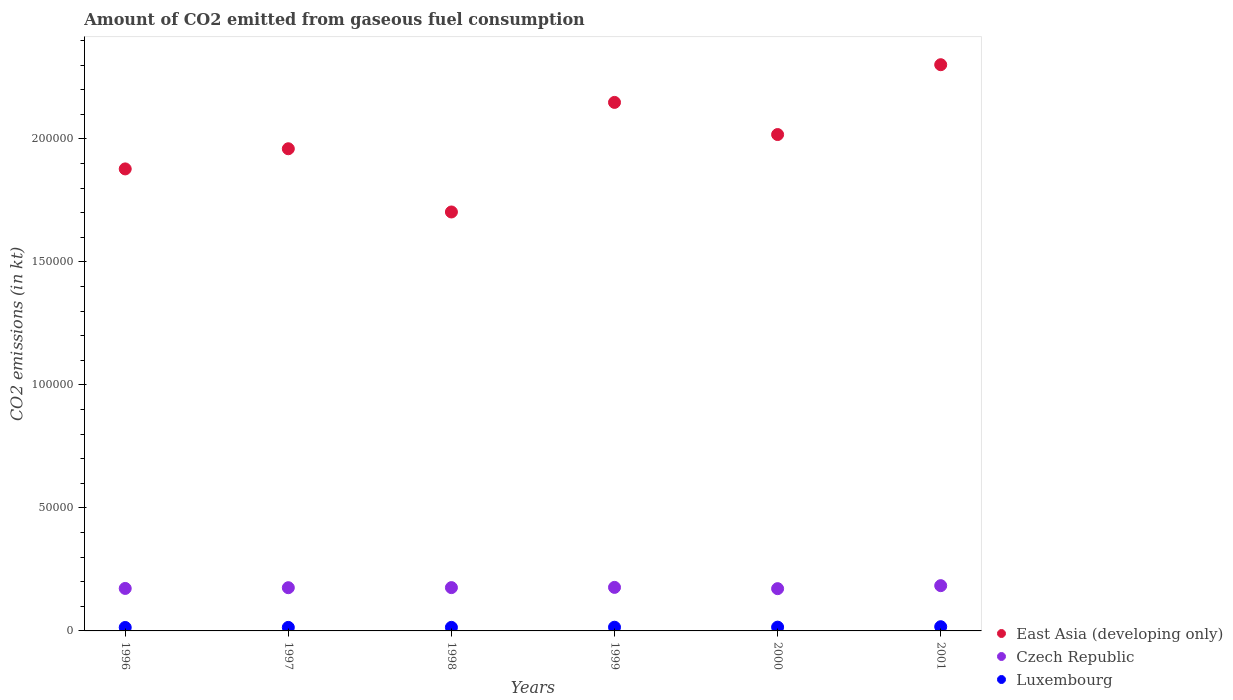What is the amount of CO2 emitted in East Asia (developing only) in 1996?
Offer a terse response. 1.88e+05. Across all years, what is the maximum amount of CO2 emitted in Luxembourg?
Provide a short and direct response. 1708.82. Across all years, what is the minimum amount of CO2 emitted in Luxembourg?
Your answer should be very brief. 1400.79. In which year was the amount of CO2 emitted in Luxembourg maximum?
Your answer should be very brief. 2001. What is the total amount of CO2 emitted in East Asia (developing only) in the graph?
Your answer should be compact. 1.20e+06. What is the difference between the amount of CO2 emitted in Luxembourg in 1996 and that in 2001?
Keep it short and to the point. -308.03. What is the difference between the amount of CO2 emitted in Luxembourg in 1998 and the amount of CO2 emitted in Czech Republic in 1997?
Ensure brevity in your answer.  -1.61e+04. What is the average amount of CO2 emitted in East Asia (developing only) per year?
Make the answer very short. 2.00e+05. In the year 1996, what is the difference between the amount of CO2 emitted in Luxembourg and amount of CO2 emitted in East Asia (developing only)?
Your answer should be compact. -1.86e+05. In how many years, is the amount of CO2 emitted in East Asia (developing only) greater than 50000 kt?
Your response must be concise. 6. What is the ratio of the amount of CO2 emitted in Luxembourg in 1999 to that in 2000?
Provide a succinct answer. 0.98. Is the amount of CO2 emitted in Luxembourg in 1997 less than that in 2001?
Your answer should be very brief. Yes. What is the difference between the highest and the second highest amount of CO2 emitted in Czech Republic?
Make the answer very short. 700.4. What is the difference between the highest and the lowest amount of CO2 emitted in Czech Republic?
Your response must be concise. 1221.11. In how many years, is the amount of CO2 emitted in Czech Republic greater than the average amount of CO2 emitted in Czech Republic taken over all years?
Keep it short and to the point. 2. Is the sum of the amount of CO2 emitted in Luxembourg in 1998 and 2000 greater than the maximum amount of CO2 emitted in East Asia (developing only) across all years?
Give a very brief answer. No. Is it the case that in every year, the sum of the amount of CO2 emitted in Czech Republic and amount of CO2 emitted in Luxembourg  is greater than the amount of CO2 emitted in East Asia (developing only)?
Your response must be concise. No. Does the amount of CO2 emitted in East Asia (developing only) monotonically increase over the years?
Ensure brevity in your answer.  No. How many dotlines are there?
Make the answer very short. 3. Does the graph contain any zero values?
Ensure brevity in your answer.  No. How are the legend labels stacked?
Provide a short and direct response. Vertical. What is the title of the graph?
Your response must be concise. Amount of CO2 emitted from gaseous fuel consumption. Does "Albania" appear as one of the legend labels in the graph?
Provide a short and direct response. No. What is the label or title of the Y-axis?
Make the answer very short. CO2 emissions (in kt). What is the CO2 emissions (in kt) in East Asia (developing only) in 1996?
Your answer should be compact. 1.88e+05. What is the CO2 emissions (in kt) of Czech Republic in 1996?
Provide a short and direct response. 1.73e+04. What is the CO2 emissions (in kt) in Luxembourg in 1996?
Ensure brevity in your answer.  1400.79. What is the CO2 emissions (in kt) of East Asia (developing only) in 1997?
Keep it short and to the point. 1.96e+05. What is the CO2 emissions (in kt) of Czech Republic in 1997?
Your response must be concise. 1.76e+04. What is the CO2 emissions (in kt) in Luxembourg in 1997?
Your response must be concise. 1433.8. What is the CO2 emissions (in kt) of East Asia (developing only) in 1998?
Provide a succinct answer. 1.70e+05. What is the CO2 emissions (in kt) of Czech Republic in 1998?
Your answer should be compact. 1.76e+04. What is the CO2 emissions (in kt) in Luxembourg in 1998?
Ensure brevity in your answer.  1448.46. What is the CO2 emissions (in kt) of East Asia (developing only) in 1999?
Give a very brief answer. 2.15e+05. What is the CO2 emissions (in kt) in Czech Republic in 1999?
Make the answer very short. 1.77e+04. What is the CO2 emissions (in kt) in Luxembourg in 1999?
Your answer should be compact. 1503.47. What is the CO2 emissions (in kt) of East Asia (developing only) in 2000?
Offer a very short reply. 2.02e+05. What is the CO2 emissions (in kt) in Czech Republic in 2000?
Make the answer very short. 1.72e+04. What is the CO2 emissions (in kt) in Luxembourg in 2000?
Keep it short and to the point. 1536.47. What is the CO2 emissions (in kt) of East Asia (developing only) in 2001?
Your answer should be very brief. 2.30e+05. What is the CO2 emissions (in kt) in Czech Republic in 2001?
Give a very brief answer. 1.84e+04. What is the CO2 emissions (in kt) in Luxembourg in 2001?
Ensure brevity in your answer.  1708.82. Across all years, what is the maximum CO2 emissions (in kt) in East Asia (developing only)?
Offer a terse response. 2.30e+05. Across all years, what is the maximum CO2 emissions (in kt) in Czech Republic?
Ensure brevity in your answer.  1.84e+04. Across all years, what is the maximum CO2 emissions (in kt) of Luxembourg?
Your answer should be very brief. 1708.82. Across all years, what is the minimum CO2 emissions (in kt) of East Asia (developing only)?
Provide a short and direct response. 1.70e+05. Across all years, what is the minimum CO2 emissions (in kt) of Czech Republic?
Your answer should be very brief. 1.72e+04. Across all years, what is the minimum CO2 emissions (in kt) in Luxembourg?
Provide a short and direct response. 1400.79. What is the total CO2 emissions (in kt) of East Asia (developing only) in the graph?
Provide a short and direct response. 1.20e+06. What is the total CO2 emissions (in kt) of Czech Republic in the graph?
Your response must be concise. 1.06e+05. What is the total CO2 emissions (in kt) of Luxembourg in the graph?
Your response must be concise. 9031.82. What is the difference between the CO2 emissions (in kt) in East Asia (developing only) in 1996 and that in 1997?
Ensure brevity in your answer.  -8193. What is the difference between the CO2 emissions (in kt) in Czech Republic in 1996 and that in 1997?
Provide a succinct answer. -297.03. What is the difference between the CO2 emissions (in kt) in Luxembourg in 1996 and that in 1997?
Provide a succinct answer. -33. What is the difference between the CO2 emissions (in kt) of East Asia (developing only) in 1996 and that in 1998?
Ensure brevity in your answer.  1.75e+04. What is the difference between the CO2 emissions (in kt) in Czech Republic in 1996 and that in 1998?
Ensure brevity in your answer.  -333.7. What is the difference between the CO2 emissions (in kt) in Luxembourg in 1996 and that in 1998?
Offer a terse response. -47.67. What is the difference between the CO2 emissions (in kt) of East Asia (developing only) in 1996 and that in 1999?
Your answer should be compact. -2.70e+04. What is the difference between the CO2 emissions (in kt) of Czech Republic in 1996 and that in 1999?
Your answer should be compact. -429.04. What is the difference between the CO2 emissions (in kt) in Luxembourg in 1996 and that in 1999?
Give a very brief answer. -102.68. What is the difference between the CO2 emissions (in kt) in East Asia (developing only) in 1996 and that in 2000?
Provide a short and direct response. -1.40e+04. What is the difference between the CO2 emissions (in kt) of Czech Republic in 1996 and that in 2000?
Provide a succinct answer. 91.67. What is the difference between the CO2 emissions (in kt) in Luxembourg in 1996 and that in 2000?
Provide a succinct answer. -135.68. What is the difference between the CO2 emissions (in kt) in East Asia (developing only) in 1996 and that in 2001?
Your answer should be very brief. -4.24e+04. What is the difference between the CO2 emissions (in kt) of Czech Republic in 1996 and that in 2001?
Your response must be concise. -1129.44. What is the difference between the CO2 emissions (in kt) of Luxembourg in 1996 and that in 2001?
Your answer should be very brief. -308.03. What is the difference between the CO2 emissions (in kt) in East Asia (developing only) in 1997 and that in 1998?
Your answer should be compact. 2.57e+04. What is the difference between the CO2 emissions (in kt) in Czech Republic in 1997 and that in 1998?
Your answer should be compact. -36.67. What is the difference between the CO2 emissions (in kt) of Luxembourg in 1997 and that in 1998?
Offer a terse response. -14.67. What is the difference between the CO2 emissions (in kt) of East Asia (developing only) in 1997 and that in 1999?
Offer a very short reply. -1.88e+04. What is the difference between the CO2 emissions (in kt) of Czech Republic in 1997 and that in 1999?
Make the answer very short. -132.01. What is the difference between the CO2 emissions (in kt) of Luxembourg in 1997 and that in 1999?
Offer a very short reply. -69.67. What is the difference between the CO2 emissions (in kt) of East Asia (developing only) in 1997 and that in 2000?
Give a very brief answer. -5774.36. What is the difference between the CO2 emissions (in kt) of Czech Republic in 1997 and that in 2000?
Keep it short and to the point. 388.7. What is the difference between the CO2 emissions (in kt) of Luxembourg in 1997 and that in 2000?
Provide a succinct answer. -102.68. What is the difference between the CO2 emissions (in kt) of East Asia (developing only) in 1997 and that in 2001?
Offer a very short reply. -3.42e+04. What is the difference between the CO2 emissions (in kt) of Czech Republic in 1997 and that in 2001?
Offer a very short reply. -832.41. What is the difference between the CO2 emissions (in kt) in Luxembourg in 1997 and that in 2001?
Make the answer very short. -275.02. What is the difference between the CO2 emissions (in kt) of East Asia (developing only) in 1998 and that in 1999?
Your answer should be very brief. -4.45e+04. What is the difference between the CO2 emissions (in kt) of Czech Republic in 1998 and that in 1999?
Your answer should be very brief. -95.34. What is the difference between the CO2 emissions (in kt) in Luxembourg in 1998 and that in 1999?
Keep it short and to the point. -55.01. What is the difference between the CO2 emissions (in kt) in East Asia (developing only) in 1998 and that in 2000?
Provide a succinct answer. -3.15e+04. What is the difference between the CO2 emissions (in kt) in Czech Republic in 1998 and that in 2000?
Your answer should be compact. 425.37. What is the difference between the CO2 emissions (in kt) in Luxembourg in 1998 and that in 2000?
Provide a succinct answer. -88.01. What is the difference between the CO2 emissions (in kt) in East Asia (developing only) in 1998 and that in 2001?
Your answer should be compact. -5.99e+04. What is the difference between the CO2 emissions (in kt) in Czech Republic in 1998 and that in 2001?
Keep it short and to the point. -795.74. What is the difference between the CO2 emissions (in kt) in Luxembourg in 1998 and that in 2001?
Give a very brief answer. -260.36. What is the difference between the CO2 emissions (in kt) of East Asia (developing only) in 1999 and that in 2000?
Your response must be concise. 1.31e+04. What is the difference between the CO2 emissions (in kt) of Czech Republic in 1999 and that in 2000?
Provide a succinct answer. 520.71. What is the difference between the CO2 emissions (in kt) in Luxembourg in 1999 and that in 2000?
Keep it short and to the point. -33. What is the difference between the CO2 emissions (in kt) in East Asia (developing only) in 1999 and that in 2001?
Give a very brief answer. -1.53e+04. What is the difference between the CO2 emissions (in kt) in Czech Republic in 1999 and that in 2001?
Offer a terse response. -700.4. What is the difference between the CO2 emissions (in kt) in Luxembourg in 1999 and that in 2001?
Keep it short and to the point. -205.35. What is the difference between the CO2 emissions (in kt) in East Asia (developing only) in 2000 and that in 2001?
Provide a succinct answer. -2.84e+04. What is the difference between the CO2 emissions (in kt) in Czech Republic in 2000 and that in 2001?
Offer a terse response. -1221.11. What is the difference between the CO2 emissions (in kt) in Luxembourg in 2000 and that in 2001?
Provide a short and direct response. -172.35. What is the difference between the CO2 emissions (in kt) in East Asia (developing only) in 1996 and the CO2 emissions (in kt) in Czech Republic in 1997?
Offer a terse response. 1.70e+05. What is the difference between the CO2 emissions (in kt) in East Asia (developing only) in 1996 and the CO2 emissions (in kt) in Luxembourg in 1997?
Make the answer very short. 1.86e+05. What is the difference between the CO2 emissions (in kt) of Czech Republic in 1996 and the CO2 emissions (in kt) of Luxembourg in 1997?
Offer a very short reply. 1.58e+04. What is the difference between the CO2 emissions (in kt) in East Asia (developing only) in 1996 and the CO2 emissions (in kt) in Czech Republic in 1998?
Provide a short and direct response. 1.70e+05. What is the difference between the CO2 emissions (in kt) in East Asia (developing only) in 1996 and the CO2 emissions (in kt) in Luxembourg in 1998?
Provide a succinct answer. 1.86e+05. What is the difference between the CO2 emissions (in kt) of Czech Republic in 1996 and the CO2 emissions (in kt) of Luxembourg in 1998?
Give a very brief answer. 1.58e+04. What is the difference between the CO2 emissions (in kt) in East Asia (developing only) in 1996 and the CO2 emissions (in kt) in Czech Republic in 1999?
Make the answer very short. 1.70e+05. What is the difference between the CO2 emissions (in kt) in East Asia (developing only) in 1996 and the CO2 emissions (in kt) in Luxembourg in 1999?
Offer a very short reply. 1.86e+05. What is the difference between the CO2 emissions (in kt) in Czech Republic in 1996 and the CO2 emissions (in kt) in Luxembourg in 1999?
Offer a very short reply. 1.58e+04. What is the difference between the CO2 emissions (in kt) of East Asia (developing only) in 1996 and the CO2 emissions (in kt) of Czech Republic in 2000?
Provide a short and direct response. 1.71e+05. What is the difference between the CO2 emissions (in kt) in East Asia (developing only) in 1996 and the CO2 emissions (in kt) in Luxembourg in 2000?
Make the answer very short. 1.86e+05. What is the difference between the CO2 emissions (in kt) of Czech Republic in 1996 and the CO2 emissions (in kt) of Luxembourg in 2000?
Provide a short and direct response. 1.57e+04. What is the difference between the CO2 emissions (in kt) of East Asia (developing only) in 1996 and the CO2 emissions (in kt) of Czech Republic in 2001?
Give a very brief answer. 1.69e+05. What is the difference between the CO2 emissions (in kt) of East Asia (developing only) in 1996 and the CO2 emissions (in kt) of Luxembourg in 2001?
Offer a terse response. 1.86e+05. What is the difference between the CO2 emissions (in kt) of Czech Republic in 1996 and the CO2 emissions (in kt) of Luxembourg in 2001?
Your answer should be compact. 1.56e+04. What is the difference between the CO2 emissions (in kt) in East Asia (developing only) in 1997 and the CO2 emissions (in kt) in Czech Republic in 1998?
Offer a very short reply. 1.78e+05. What is the difference between the CO2 emissions (in kt) in East Asia (developing only) in 1997 and the CO2 emissions (in kt) in Luxembourg in 1998?
Your answer should be very brief. 1.95e+05. What is the difference between the CO2 emissions (in kt) in Czech Republic in 1997 and the CO2 emissions (in kt) in Luxembourg in 1998?
Give a very brief answer. 1.61e+04. What is the difference between the CO2 emissions (in kt) in East Asia (developing only) in 1997 and the CO2 emissions (in kt) in Czech Republic in 1999?
Your response must be concise. 1.78e+05. What is the difference between the CO2 emissions (in kt) in East Asia (developing only) in 1997 and the CO2 emissions (in kt) in Luxembourg in 1999?
Keep it short and to the point. 1.94e+05. What is the difference between the CO2 emissions (in kt) in Czech Republic in 1997 and the CO2 emissions (in kt) in Luxembourg in 1999?
Make the answer very short. 1.61e+04. What is the difference between the CO2 emissions (in kt) of East Asia (developing only) in 1997 and the CO2 emissions (in kt) of Czech Republic in 2000?
Your answer should be very brief. 1.79e+05. What is the difference between the CO2 emissions (in kt) in East Asia (developing only) in 1997 and the CO2 emissions (in kt) in Luxembourg in 2000?
Offer a very short reply. 1.94e+05. What is the difference between the CO2 emissions (in kt) of Czech Republic in 1997 and the CO2 emissions (in kt) of Luxembourg in 2000?
Your answer should be very brief. 1.60e+04. What is the difference between the CO2 emissions (in kt) of East Asia (developing only) in 1997 and the CO2 emissions (in kt) of Czech Republic in 2001?
Give a very brief answer. 1.78e+05. What is the difference between the CO2 emissions (in kt) in East Asia (developing only) in 1997 and the CO2 emissions (in kt) in Luxembourg in 2001?
Keep it short and to the point. 1.94e+05. What is the difference between the CO2 emissions (in kt) of Czech Republic in 1997 and the CO2 emissions (in kt) of Luxembourg in 2001?
Your answer should be compact. 1.59e+04. What is the difference between the CO2 emissions (in kt) in East Asia (developing only) in 1998 and the CO2 emissions (in kt) in Czech Republic in 1999?
Your response must be concise. 1.53e+05. What is the difference between the CO2 emissions (in kt) in East Asia (developing only) in 1998 and the CO2 emissions (in kt) in Luxembourg in 1999?
Provide a succinct answer. 1.69e+05. What is the difference between the CO2 emissions (in kt) of Czech Republic in 1998 and the CO2 emissions (in kt) of Luxembourg in 1999?
Give a very brief answer. 1.61e+04. What is the difference between the CO2 emissions (in kt) of East Asia (developing only) in 1998 and the CO2 emissions (in kt) of Czech Republic in 2000?
Provide a short and direct response. 1.53e+05. What is the difference between the CO2 emissions (in kt) in East Asia (developing only) in 1998 and the CO2 emissions (in kt) in Luxembourg in 2000?
Your answer should be compact. 1.69e+05. What is the difference between the CO2 emissions (in kt) in Czech Republic in 1998 and the CO2 emissions (in kt) in Luxembourg in 2000?
Offer a very short reply. 1.61e+04. What is the difference between the CO2 emissions (in kt) of East Asia (developing only) in 1998 and the CO2 emissions (in kt) of Czech Republic in 2001?
Your answer should be very brief. 1.52e+05. What is the difference between the CO2 emissions (in kt) of East Asia (developing only) in 1998 and the CO2 emissions (in kt) of Luxembourg in 2001?
Your response must be concise. 1.69e+05. What is the difference between the CO2 emissions (in kt) in Czech Republic in 1998 and the CO2 emissions (in kt) in Luxembourg in 2001?
Give a very brief answer. 1.59e+04. What is the difference between the CO2 emissions (in kt) of East Asia (developing only) in 1999 and the CO2 emissions (in kt) of Czech Republic in 2000?
Your answer should be very brief. 1.98e+05. What is the difference between the CO2 emissions (in kt) of East Asia (developing only) in 1999 and the CO2 emissions (in kt) of Luxembourg in 2000?
Give a very brief answer. 2.13e+05. What is the difference between the CO2 emissions (in kt) of Czech Republic in 1999 and the CO2 emissions (in kt) of Luxembourg in 2000?
Offer a very short reply. 1.62e+04. What is the difference between the CO2 emissions (in kt) in East Asia (developing only) in 1999 and the CO2 emissions (in kt) in Czech Republic in 2001?
Make the answer very short. 1.96e+05. What is the difference between the CO2 emissions (in kt) in East Asia (developing only) in 1999 and the CO2 emissions (in kt) in Luxembourg in 2001?
Keep it short and to the point. 2.13e+05. What is the difference between the CO2 emissions (in kt) of Czech Republic in 1999 and the CO2 emissions (in kt) of Luxembourg in 2001?
Ensure brevity in your answer.  1.60e+04. What is the difference between the CO2 emissions (in kt) of East Asia (developing only) in 2000 and the CO2 emissions (in kt) of Czech Republic in 2001?
Provide a succinct answer. 1.83e+05. What is the difference between the CO2 emissions (in kt) in East Asia (developing only) in 2000 and the CO2 emissions (in kt) in Luxembourg in 2001?
Offer a terse response. 2.00e+05. What is the difference between the CO2 emissions (in kt) of Czech Republic in 2000 and the CO2 emissions (in kt) of Luxembourg in 2001?
Give a very brief answer. 1.55e+04. What is the average CO2 emissions (in kt) of East Asia (developing only) per year?
Keep it short and to the point. 2.00e+05. What is the average CO2 emissions (in kt) of Czech Republic per year?
Make the answer very short. 1.76e+04. What is the average CO2 emissions (in kt) of Luxembourg per year?
Your answer should be very brief. 1505.3. In the year 1996, what is the difference between the CO2 emissions (in kt) of East Asia (developing only) and CO2 emissions (in kt) of Czech Republic?
Your response must be concise. 1.71e+05. In the year 1996, what is the difference between the CO2 emissions (in kt) of East Asia (developing only) and CO2 emissions (in kt) of Luxembourg?
Provide a succinct answer. 1.86e+05. In the year 1996, what is the difference between the CO2 emissions (in kt) of Czech Republic and CO2 emissions (in kt) of Luxembourg?
Offer a terse response. 1.59e+04. In the year 1997, what is the difference between the CO2 emissions (in kt) of East Asia (developing only) and CO2 emissions (in kt) of Czech Republic?
Your response must be concise. 1.78e+05. In the year 1997, what is the difference between the CO2 emissions (in kt) in East Asia (developing only) and CO2 emissions (in kt) in Luxembourg?
Your response must be concise. 1.95e+05. In the year 1997, what is the difference between the CO2 emissions (in kt) in Czech Republic and CO2 emissions (in kt) in Luxembourg?
Give a very brief answer. 1.61e+04. In the year 1998, what is the difference between the CO2 emissions (in kt) of East Asia (developing only) and CO2 emissions (in kt) of Czech Republic?
Your response must be concise. 1.53e+05. In the year 1998, what is the difference between the CO2 emissions (in kt) of East Asia (developing only) and CO2 emissions (in kt) of Luxembourg?
Your answer should be compact. 1.69e+05. In the year 1998, what is the difference between the CO2 emissions (in kt) in Czech Republic and CO2 emissions (in kt) in Luxembourg?
Offer a terse response. 1.62e+04. In the year 1999, what is the difference between the CO2 emissions (in kt) of East Asia (developing only) and CO2 emissions (in kt) of Czech Republic?
Provide a succinct answer. 1.97e+05. In the year 1999, what is the difference between the CO2 emissions (in kt) in East Asia (developing only) and CO2 emissions (in kt) in Luxembourg?
Give a very brief answer. 2.13e+05. In the year 1999, what is the difference between the CO2 emissions (in kt) in Czech Republic and CO2 emissions (in kt) in Luxembourg?
Ensure brevity in your answer.  1.62e+04. In the year 2000, what is the difference between the CO2 emissions (in kt) of East Asia (developing only) and CO2 emissions (in kt) of Czech Republic?
Provide a short and direct response. 1.85e+05. In the year 2000, what is the difference between the CO2 emissions (in kt) of East Asia (developing only) and CO2 emissions (in kt) of Luxembourg?
Provide a succinct answer. 2.00e+05. In the year 2000, what is the difference between the CO2 emissions (in kt) in Czech Republic and CO2 emissions (in kt) in Luxembourg?
Your response must be concise. 1.56e+04. In the year 2001, what is the difference between the CO2 emissions (in kt) of East Asia (developing only) and CO2 emissions (in kt) of Czech Republic?
Your response must be concise. 2.12e+05. In the year 2001, what is the difference between the CO2 emissions (in kt) of East Asia (developing only) and CO2 emissions (in kt) of Luxembourg?
Give a very brief answer. 2.28e+05. In the year 2001, what is the difference between the CO2 emissions (in kt) in Czech Republic and CO2 emissions (in kt) in Luxembourg?
Offer a terse response. 1.67e+04. What is the ratio of the CO2 emissions (in kt) in East Asia (developing only) in 1996 to that in 1997?
Offer a terse response. 0.96. What is the ratio of the CO2 emissions (in kt) in Czech Republic in 1996 to that in 1997?
Your answer should be very brief. 0.98. What is the ratio of the CO2 emissions (in kt) in East Asia (developing only) in 1996 to that in 1998?
Offer a terse response. 1.1. What is the ratio of the CO2 emissions (in kt) of Czech Republic in 1996 to that in 1998?
Keep it short and to the point. 0.98. What is the ratio of the CO2 emissions (in kt) in Luxembourg in 1996 to that in 1998?
Your answer should be very brief. 0.97. What is the ratio of the CO2 emissions (in kt) in East Asia (developing only) in 1996 to that in 1999?
Provide a short and direct response. 0.87. What is the ratio of the CO2 emissions (in kt) in Czech Republic in 1996 to that in 1999?
Ensure brevity in your answer.  0.98. What is the ratio of the CO2 emissions (in kt) of Luxembourg in 1996 to that in 1999?
Offer a very short reply. 0.93. What is the ratio of the CO2 emissions (in kt) of East Asia (developing only) in 1996 to that in 2000?
Make the answer very short. 0.93. What is the ratio of the CO2 emissions (in kt) of Luxembourg in 1996 to that in 2000?
Your answer should be compact. 0.91. What is the ratio of the CO2 emissions (in kt) in East Asia (developing only) in 1996 to that in 2001?
Ensure brevity in your answer.  0.82. What is the ratio of the CO2 emissions (in kt) of Czech Republic in 1996 to that in 2001?
Offer a very short reply. 0.94. What is the ratio of the CO2 emissions (in kt) in Luxembourg in 1996 to that in 2001?
Give a very brief answer. 0.82. What is the ratio of the CO2 emissions (in kt) in East Asia (developing only) in 1997 to that in 1998?
Give a very brief answer. 1.15. What is the ratio of the CO2 emissions (in kt) of Luxembourg in 1997 to that in 1998?
Ensure brevity in your answer.  0.99. What is the ratio of the CO2 emissions (in kt) in East Asia (developing only) in 1997 to that in 1999?
Provide a succinct answer. 0.91. What is the ratio of the CO2 emissions (in kt) of Luxembourg in 1997 to that in 1999?
Ensure brevity in your answer.  0.95. What is the ratio of the CO2 emissions (in kt) in East Asia (developing only) in 1997 to that in 2000?
Your answer should be compact. 0.97. What is the ratio of the CO2 emissions (in kt) of Czech Republic in 1997 to that in 2000?
Your answer should be very brief. 1.02. What is the ratio of the CO2 emissions (in kt) of Luxembourg in 1997 to that in 2000?
Make the answer very short. 0.93. What is the ratio of the CO2 emissions (in kt) in East Asia (developing only) in 1997 to that in 2001?
Provide a succinct answer. 0.85. What is the ratio of the CO2 emissions (in kt) of Czech Republic in 1997 to that in 2001?
Offer a terse response. 0.95. What is the ratio of the CO2 emissions (in kt) in Luxembourg in 1997 to that in 2001?
Your response must be concise. 0.84. What is the ratio of the CO2 emissions (in kt) of East Asia (developing only) in 1998 to that in 1999?
Your response must be concise. 0.79. What is the ratio of the CO2 emissions (in kt) of Czech Republic in 1998 to that in 1999?
Keep it short and to the point. 0.99. What is the ratio of the CO2 emissions (in kt) of Luxembourg in 1998 to that in 1999?
Provide a short and direct response. 0.96. What is the ratio of the CO2 emissions (in kt) in East Asia (developing only) in 1998 to that in 2000?
Your answer should be very brief. 0.84. What is the ratio of the CO2 emissions (in kt) of Czech Republic in 1998 to that in 2000?
Give a very brief answer. 1.02. What is the ratio of the CO2 emissions (in kt) of Luxembourg in 1998 to that in 2000?
Ensure brevity in your answer.  0.94. What is the ratio of the CO2 emissions (in kt) in East Asia (developing only) in 1998 to that in 2001?
Give a very brief answer. 0.74. What is the ratio of the CO2 emissions (in kt) in Czech Republic in 1998 to that in 2001?
Offer a terse response. 0.96. What is the ratio of the CO2 emissions (in kt) of Luxembourg in 1998 to that in 2001?
Ensure brevity in your answer.  0.85. What is the ratio of the CO2 emissions (in kt) in East Asia (developing only) in 1999 to that in 2000?
Provide a succinct answer. 1.06. What is the ratio of the CO2 emissions (in kt) of Czech Republic in 1999 to that in 2000?
Provide a succinct answer. 1.03. What is the ratio of the CO2 emissions (in kt) of Luxembourg in 1999 to that in 2000?
Provide a short and direct response. 0.98. What is the ratio of the CO2 emissions (in kt) of East Asia (developing only) in 1999 to that in 2001?
Offer a very short reply. 0.93. What is the ratio of the CO2 emissions (in kt) in Czech Republic in 1999 to that in 2001?
Make the answer very short. 0.96. What is the ratio of the CO2 emissions (in kt) of Luxembourg in 1999 to that in 2001?
Keep it short and to the point. 0.88. What is the ratio of the CO2 emissions (in kt) in East Asia (developing only) in 2000 to that in 2001?
Make the answer very short. 0.88. What is the ratio of the CO2 emissions (in kt) in Czech Republic in 2000 to that in 2001?
Offer a very short reply. 0.93. What is the ratio of the CO2 emissions (in kt) of Luxembourg in 2000 to that in 2001?
Ensure brevity in your answer.  0.9. What is the difference between the highest and the second highest CO2 emissions (in kt) in East Asia (developing only)?
Keep it short and to the point. 1.53e+04. What is the difference between the highest and the second highest CO2 emissions (in kt) of Czech Republic?
Ensure brevity in your answer.  700.4. What is the difference between the highest and the second highest CO2 emissions (in kt) of Luxembourg?
Ensure brevity in your answer.  172.35. What is the difference between the highest and the lowest CO2 emissions (in kt) of East Asia (developing only)?
Make the answer very short. 5.99e+04. What is the difference between the highest and the lowest CO2 emissions (in kt) of Czech Republic?
Provide a short and direct response. 1221.11. What is the difference between the highest and the lowest CO2 emissions (in kt) in Luxembourg?
Your answer should be compact. 308.03. 